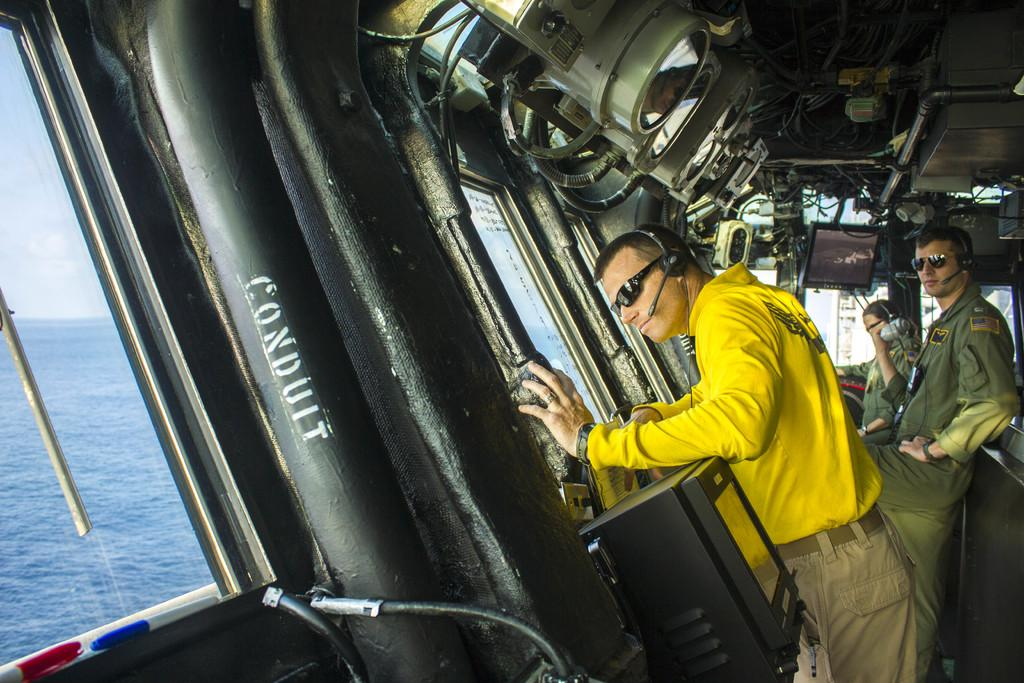What is the main subject of the image? The main subject of the image is a ship. Where is the ship located? The ship is on the water. How many people are on the ship? There are three persons standing in the ship. What are the people wearing? The persons are wearing headphones. What can be seen in the background of the image? The sky is visible in the background of the image, and there are clouds in the sky. Where is the toad hiding in the image? There is no toad present in the image; it features a ship with people wearing headphones on the water. 